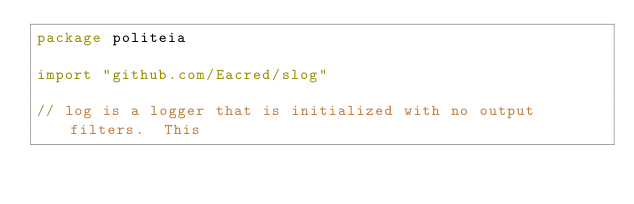<code> <loc_0><loc_0><loc_500><loc_500><_Go_>package politeia

import "github.com/Eacred/slog"

// log is a logger that is initialized with no output filters.  This</code> 